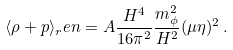Convert formula to latex. <formula><loc_0><loc_0><loc_500><loc_500>\langle \rho + p \rangle _ { r } e n = A \frac { H ^ { 4 } } { 1 6 \pi ^ { 2 } } \frac { m _ { \phi } ^ { 2 } } { H ^ { 2 } } ( \mu \eta ) ^ { 2 } \, .</formula> 